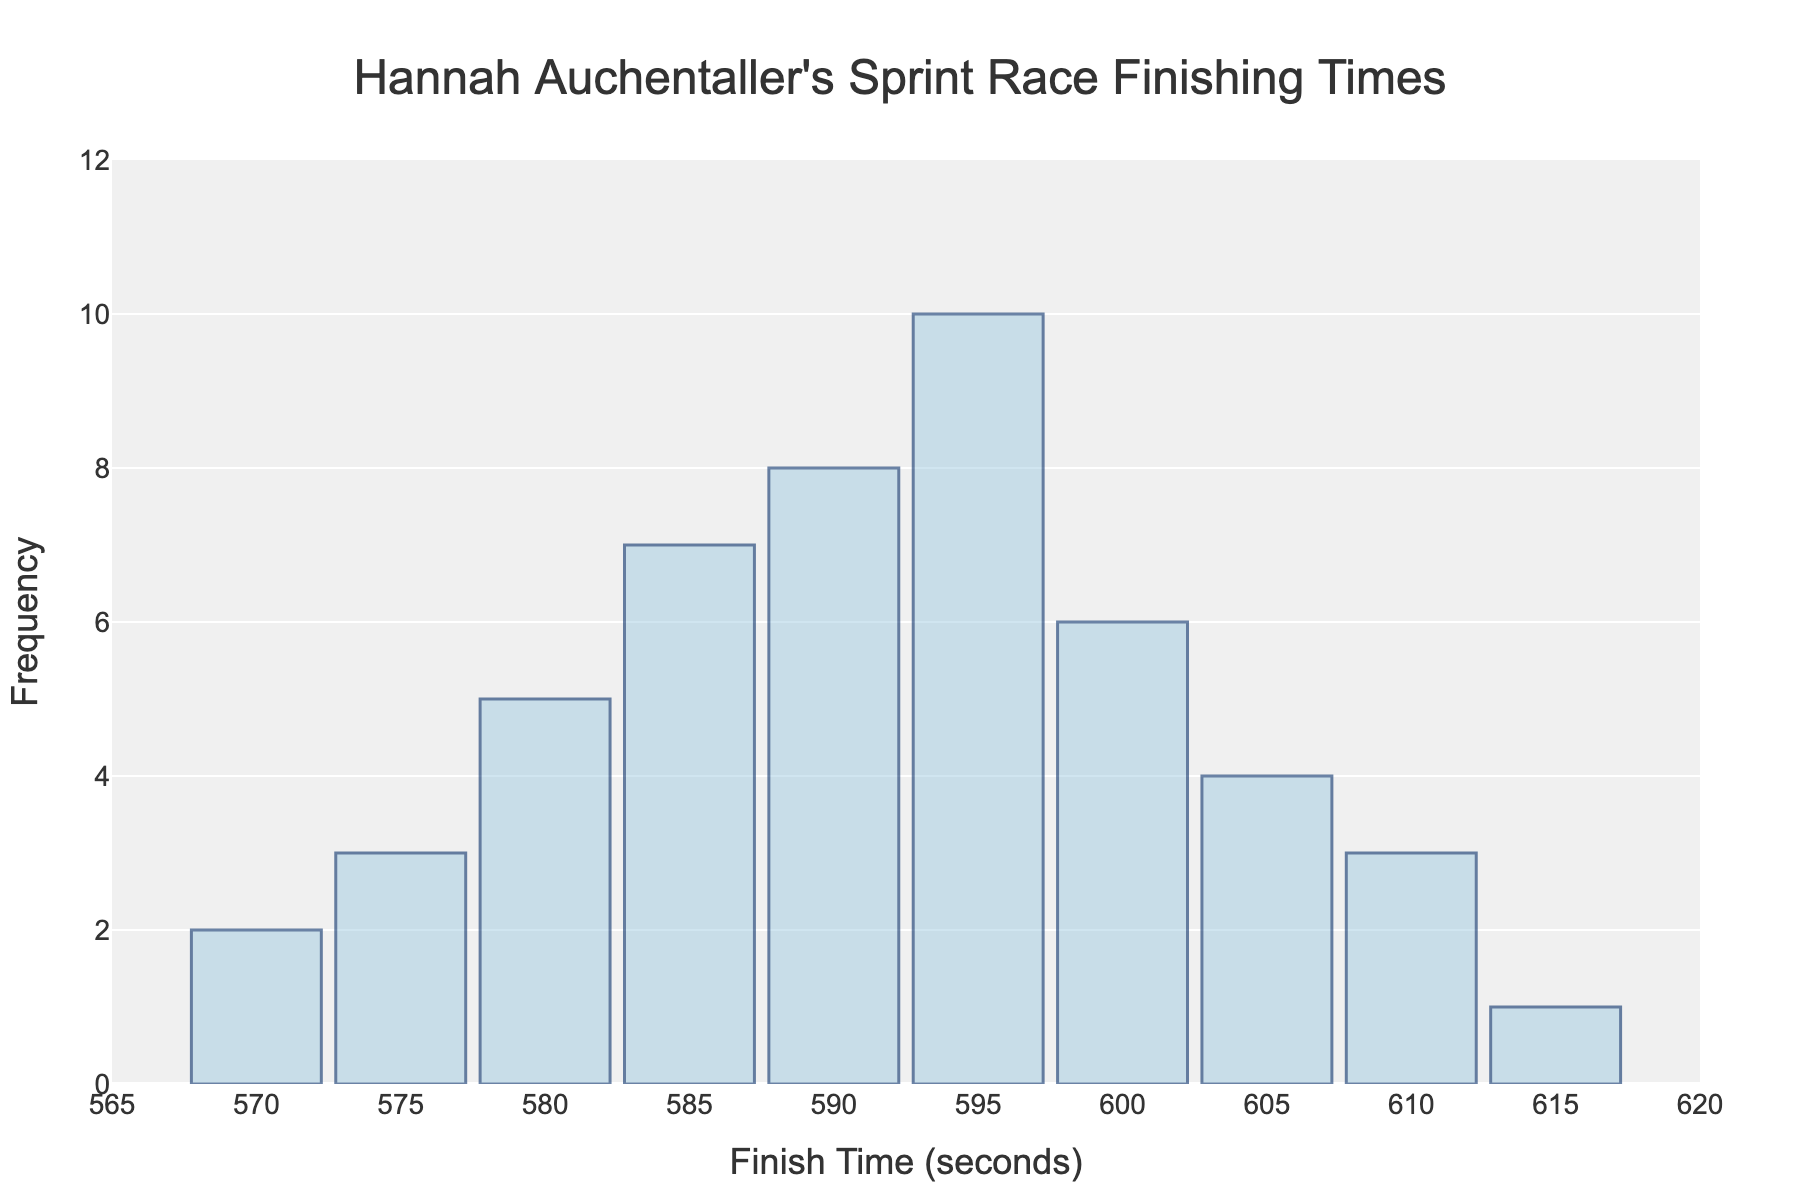What is the title of the histogram? The title of the histogram is prominently displayed at the top of the figure.
Answer: Hannah Auchentaller's Sprint Race Finishing Times What is the frequency of races that took 595 seconds to finish? Locate the bar corresponding to 595 seconds on the x-axis and look up to see the height, which touches the y-axis at 10.
Answer: 10 At which finish time does Hannah have the highest frequency of finishing? Identify the tallest bar in the histogram; the x-value is where the peak is.
Answer: 595 seconds How many races did Hannah finish between 585 and 595 seconds (inclusive)? Sum the frequencies of the time intervals 585, 590, and 595 seconds from the y-axis values.
Answer: 7+8+10 = 25 What is the total number of sprint races recorded in the histogram? Sum up all the frequency values for each finish time listed on the x-axis.
Answer: 2+3+5+7+8+10+6+4+3+1 = 49 How does the frequency of races where the finish time was 600 seconds compare to those at 605 seconds? Compare the heights of the bars for 600 seconds and 605 seconds, which are 6 and 4 respectively.
Answer: 600 seconds has 2 more races than 605 seconds What is the median finishing time for Hannah based on this histogram? List out each finish time with its frequency, and identify the middle value when they are ordered.
Answer: 595 seconds Which finish time has the lowest recorded frequency and what is it? Identify the shortest bar in the histogram and see its corresponding finishing time and the frequency value.
Answer: 615 seconds, with a frequency of 1 How much higher is the frequency of races finished at 590 seconds compared to 580 seconds? Subtract the frequency of 580 seconds' races from that of 590 seconds.
Answer: 8 - 5 = 3 What is the range of finish times depicted in the histogram? Identify the smallest and largest finish times on the x-axis.
Answer: 570 to 615 seconds 